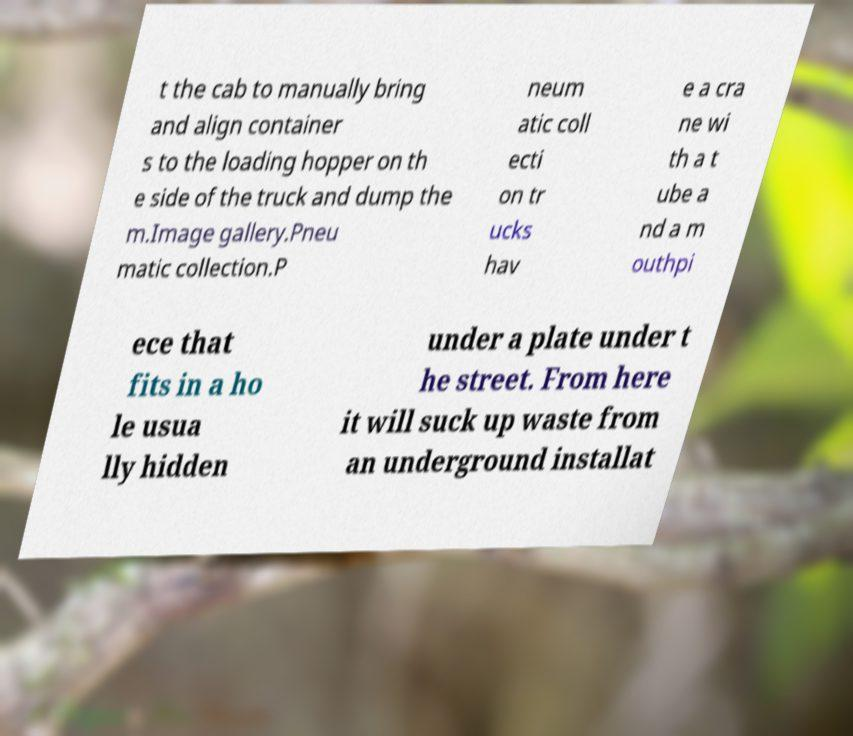Could you extract and type out the text from this image? t the cab to manually bring and align container s to the loading hopper on th e side of the truck and dump the m.Image gallery.Pneu matic collection.P neum atic coll ecti on tr ucks hav e a cra ne wi th a t ube a nd a m outhpi ece that fits in a ho le usua lly hidden under a plate under t he street. From here it will suck up waste from an underground installat 